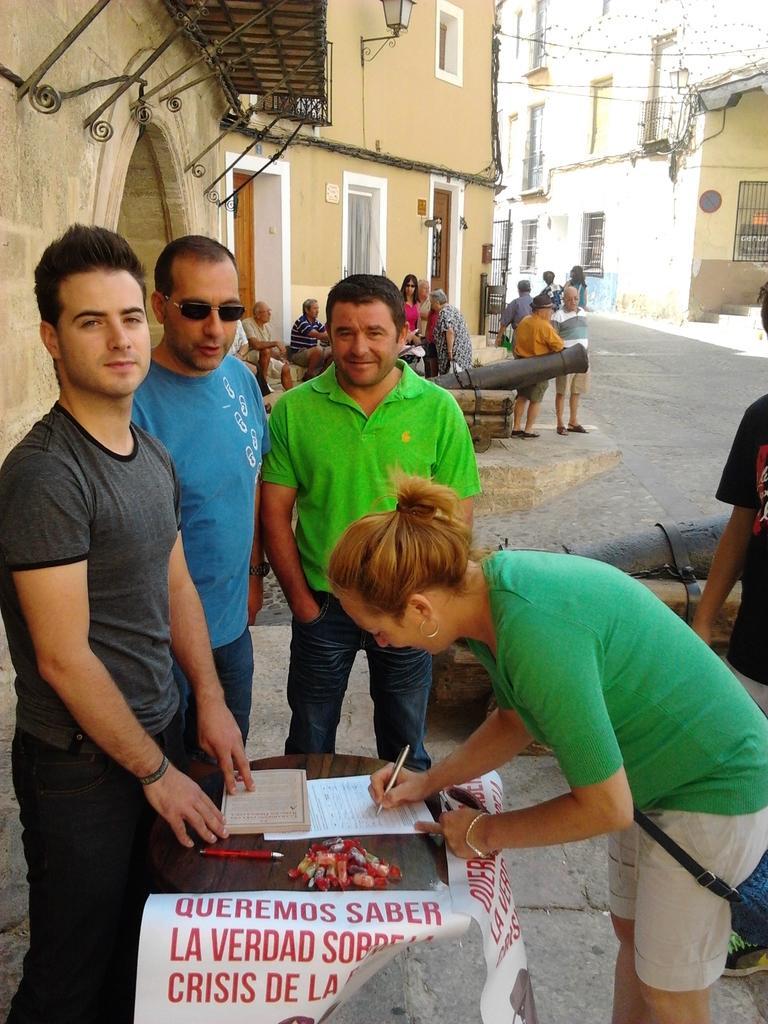Please provide a concise description of this image. In this picture we can see some people standing besides the table. And a women is bending and writing something on the paper with pen. This is road. And we can see some people are standing here. These are the buildings and this is window. There is a door. 